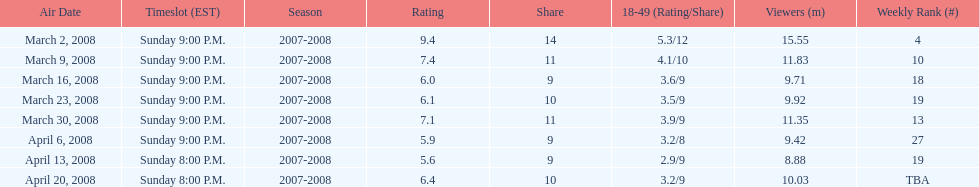Which episode received the top rating? March 2, 2008. 